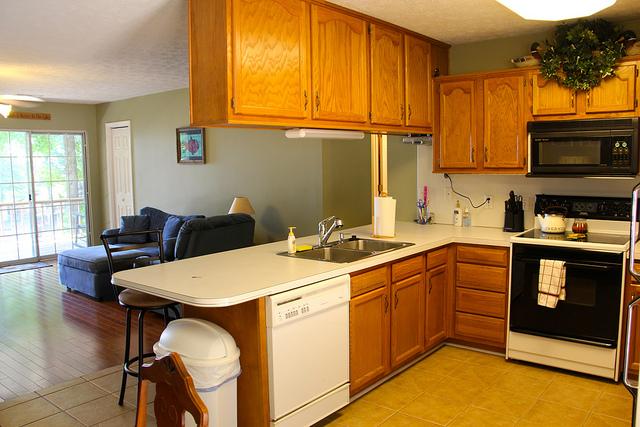What room is this?
Be succinct. Kitchen. What color is the cooking stove?
Write a very short answer. White. Is there any food inside the stove?
Give a very brief answer. No. 